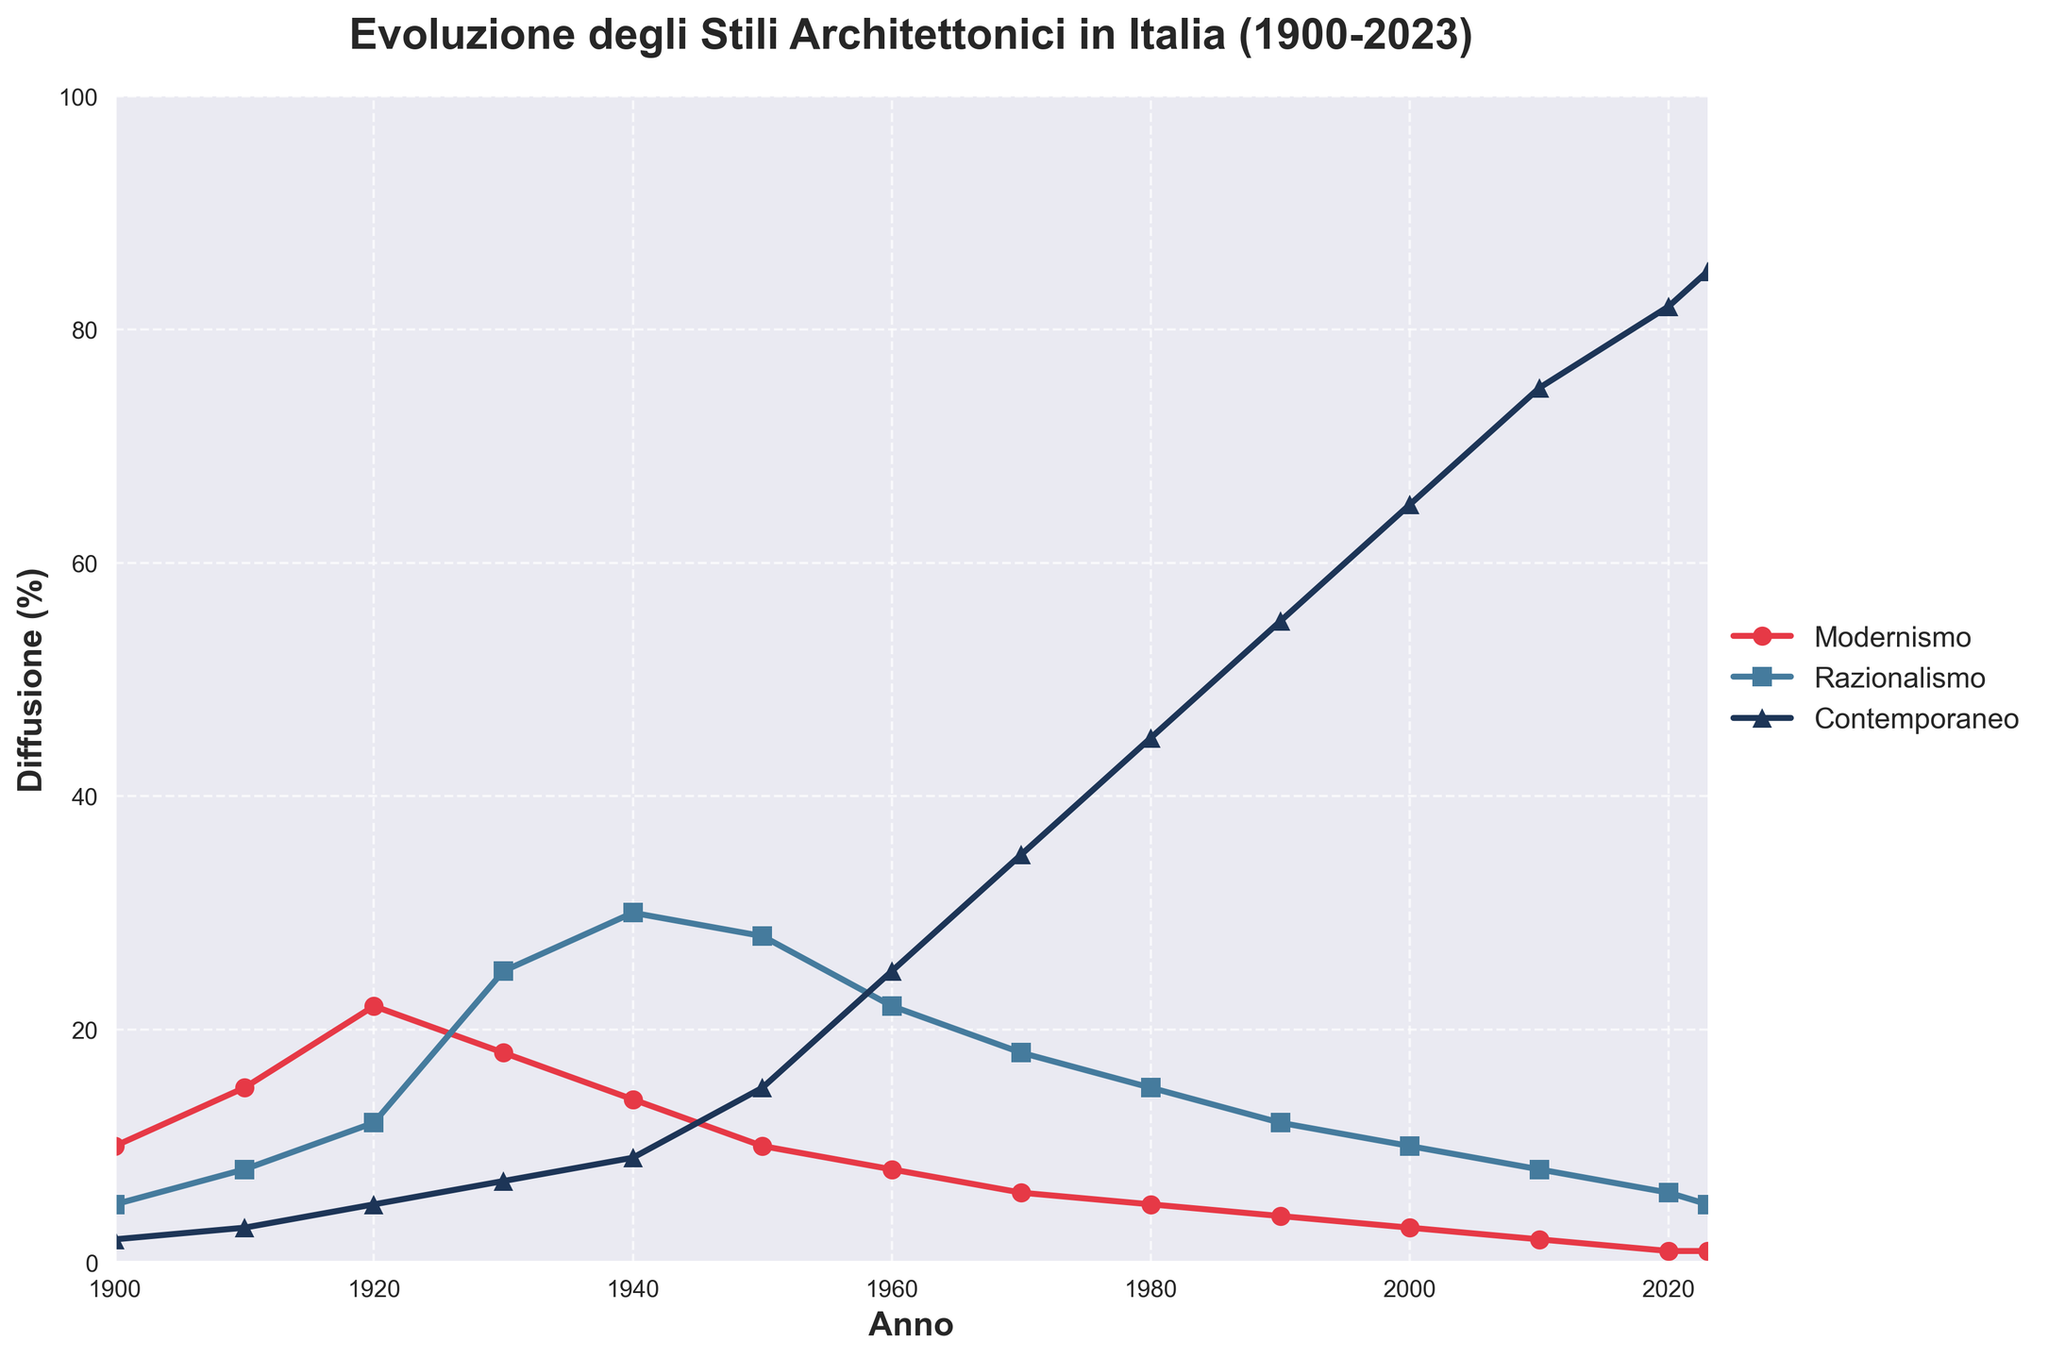What's the trend of the modernismo style from 1900 to 2023? The modernismo style starts at 10 in 1900, peaks at 22 in 1920, and then steadily declines to 1 by 2020, remaining at 1 up to 2023.
Answer: Declining In which decade did razionalismo experience the most significant growth? Between 1920 and 1930, the razionalismo style grew from 12 to 25, indicating the most significant growth in a decade.
Answer: 1920-1930 Which architectural style surpasses the others in the 1980s? In the 1980s, contemporaneo surpasses both modernismo and razionalismo with a value of 45.
Answer: Contemporaneo Compare the diffusion of modernismo and razionalismo in 1930. Which was more predominant? In 1930, modernismo had a value of 18, while razionalismo had a value of 25.
Answer: Razionalismo Calculate the average diffusion of contemporary style from 2000 to 2023. The diffusion values for contemporary style from 2000 to 2023 are 65, 75, 82, and 85. The sum is 307; dividing by 4 gives an average of 76.75.
Answer: 76.75 Which style's diffusion sees the least change from 2010 to 2023? Modernismo's diffusion remains almost unchanged from 2 in 2010 to 1 in 2023, showing the least change.
Answer: Modernismo What is the rate of decline in modernismo from 1920 to 1960? In 1920, modernismo is at 22, and by 1960 it drops to 8. The rate of decline is (22 - 8) / (1960 - 1920) = 14 / 40 = 0.35 per year.
Answer: 0.35 per year Between which two decades does contemporaneo see the biggest increase? Contemporaneo sees the biggest increase between 1950 and 1960, going from 15 to 25, an increase of 10.
Answer: 1950-1960 How does the visual representation of razionalismo change from 1940 to 2023? The line representing razionalismo peaks around 1940 at 30 and then steadily decreases to 5 by 2023, indicated by the blue line.
Answer: Decreasing Compare the starting value and ending value of contemporaneo from 1900 to 2023. Contemporaneo starts at 2 in 1900 and ends at 85 in 2023, showing a significant increase.
Answer: Starts at 2, ends at 85 